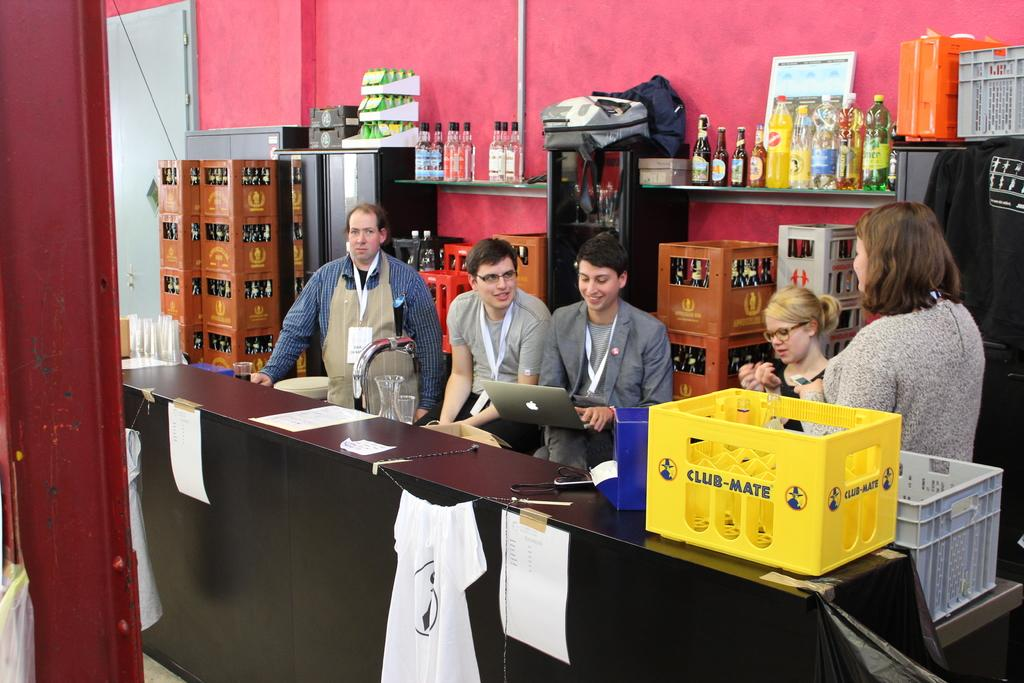<image>
Write a terse but informative summary of the picture. Five people are behind a table that has a yellow crate on it that says Club-Mate. 